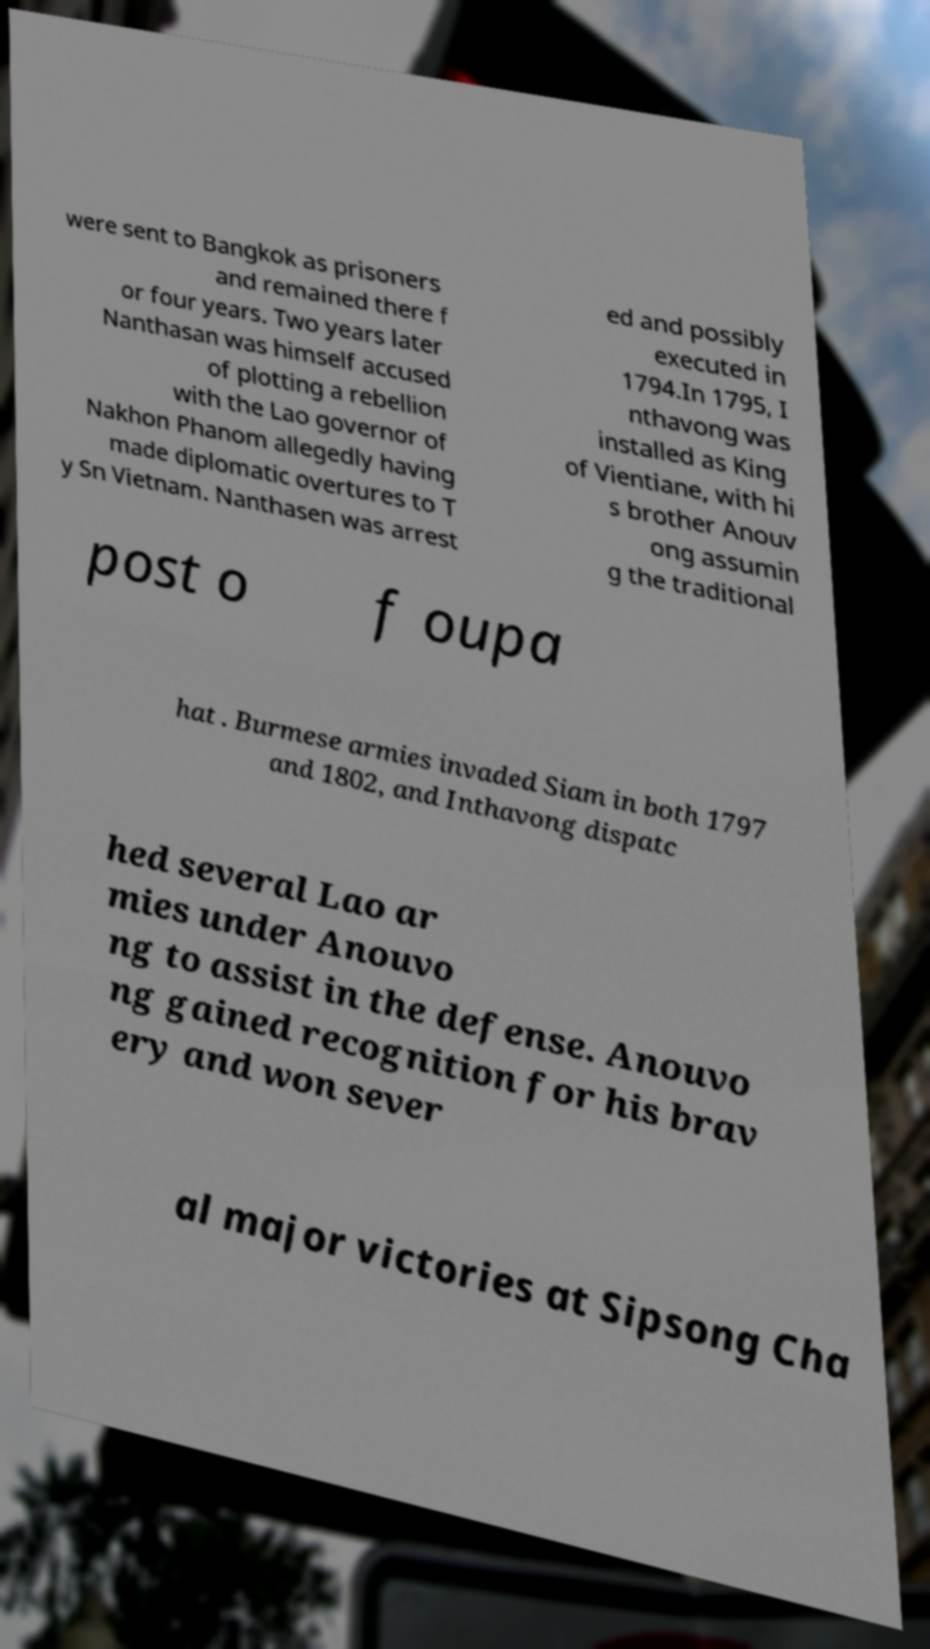Could you extract and type out the text from this image? were sent to Bangkok as prisoners and remained there f or four years. Two years later Nanthasan was himself accused of plotting a rebellion with the Lao governor of Nakhon Phanom allegedly having made diplomatic overtures to T y Sn Vietnam. Nanthasen was arrest ed and possibly executed in 1794.In 1795, I nthavong was installed as King of Vientiane, with hi s brother Anouv ong assumin g the traditional post o f oupa hat . Burmese armies invaded Siam in both 1797 and 1802, and Inthavong dispatc hed several Lao ar mies under Anouvo ng to assist in the defense. Anouvo ng gained recognition for his brav ery and won sever al major victories at Sipsong Cha 